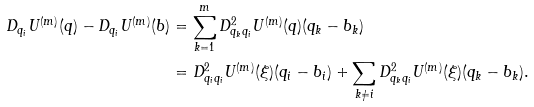<formula> <loc_0><loc_0><loc_500><loc_500>D _ { q _ { i } } U ^ { ( m ) } ( q ) - D _ { q _ { i } } U ^ { ( m ) } ( b ) & = \sum _ { k = 1 } ^ { m } D ^ { 2 } _ { q _ { k } q _ { i } } U ^ { ( m ) } ( q ) ( q _ { k } - b _ { k } ) \\ & = D ^ { 2 } _ { q _ { i } q _ { i } } U ^ { ( m ) } ( \xi ) ( q _ { i } - b _ { i } ) + \sum _ { k \neq i } D ^ { 2 } _ { q _ { k } q _ { i } } U ^ { ( m ) } ( \xi ) ( q _ { k } - b _ { k } ) .</formula> 